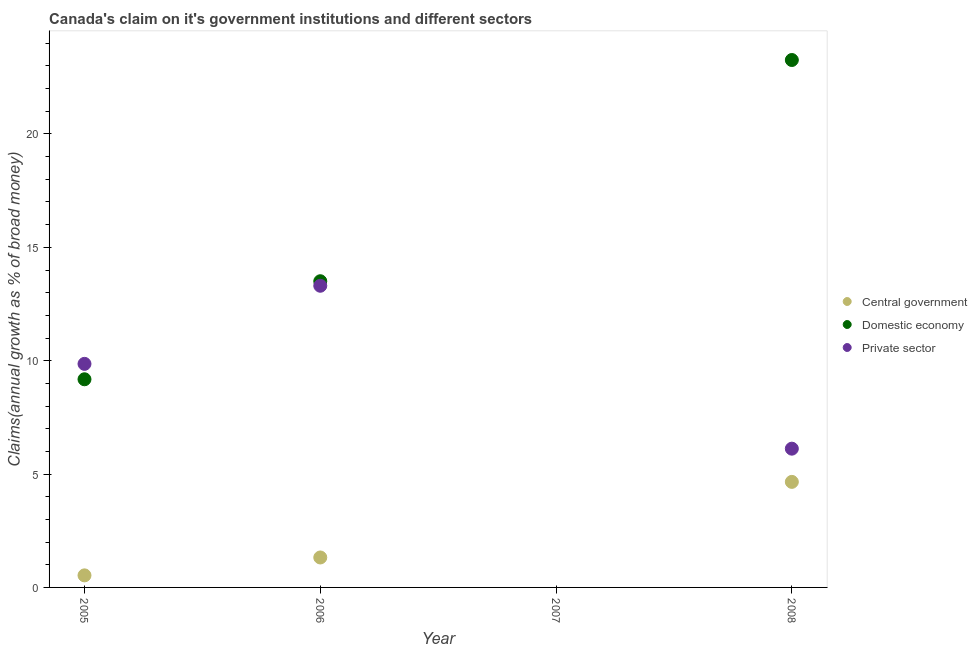Is the number of dotlines equal to the number of legend labels?
Your response must be concise. No. What is the percentage of claim on the private sector in 2006?
Offer a very short reply. 13.31. Across all years, what is the maximum percentage of claim on the domestic economy?
Provide a succinct answer. 23.26. In which year was the percentage of claim on the private sector maximum?
Your answer should be compact. 2006. What is the total percentage of claim on the central government in the graph?
Provide a short and direct response. 6.51. What is the difference between the percentage of claim on the domestic economy in 2005 and that in 2008?
Offer a terse response. -14.08. What is the difference between the percentage of claim on the private sector in 2008 and the percentage of claim on the central government in 2005?
Ensure brevity in your answer.  5.59. What is the average percentage of claim on the domestic economy per year?
Provide a short and direct response. 11.49. In the year 2005, what is the difference between the percentage of claim on the domestic economy and percentage of claim on the private sector?
Keep it short and to the point. -0.68. What is the ratio of the percentage of claim on the private sector in 2005 to that in 2006?
Provide a succinct answer. 0.74. Is the difference between the percentage of claim on the domestic economy in 2006 and 2008 greater than the difference between the percentage of claim on the central government in 2006 and 2008?
Offer a very short reply. No. What is the difference between the highest and the second highest percentage of claim on the domestic economy?
Your answer should be compact. 9.76. What is the difference between the highest and the lowest percentage of claim on the central government?
Your answer should be very brief. 4.65. In how many years, is the percentage of claim on the domestic economy greater than the average percentage of claim on the domestic economy taken over all years?
Provide a succinct answer. 2. Is it the case that in every year, the sum of the percentage of claim on the central government and percentage of claim on the domestic economy is greater than the percentage of claim on the private sector?
Make the answer very short. No. How many dotlines are there?
Your response must be concise. 3. How many years are there in the graph?
Make the answer very short. 4. Are the values on the major ticks of Y-axis written in scientific E-notation?
Offer a terse response. No. Does the graph contain grids?
Your answer should be very brief. No. How are the legend labels stacked?
Provide a short and direct response. Vertical. What is the title of the graph?
Give a very brief answer. Canada's claim on it's government institutions and different sectors. What is the label or title of the X-axis?
Ensure brevity in your answer.  Year. What is the label or title of the Y-axis?
Your response must be concise. Claims(annual growth as % of broad money). What is the Claims(annual growth as % of broad money) in Central government in 2005?
Offer a very short reply. 0.53. What is the Claims(annual growth as % of broad money) in Domestic economy in 2005?
Make the answer very short. 9.18. What is the Claims(annual growth as % of broad money) of Private sector in 2005?
Provide a short and direct response. 9.86. What is the Claims(annual growth as % of broad money) in Central government in 2006?
Your answer should be very brief. 1.32. What is the Claims(annual growth as % of broad money) of Domestic economy in 2006?
Ensure brevity in your answer.  13.5. What is the Claims(annual growth as % of broad money) of Private sector in 2006?
Offer a terse response. 13.31. What is the Claims(annual growth as % of broad money) of Central government in 2007?
Your answer should be very brief. 0. What is the Claims(annual growth as % of broad money) in Private sector in 2007?
Give a very brief answer. 0. What is the Claims(annual growth as % of broad money) of Central government in 2008?
Provide a succinct answer. 4.65. What is the Claims(annual growth as % of broad money) of Domestic economy in 2008?
Give a very brief answer. 23.26. What is the Claims(annual growth as % of broad money) in Private sector in 2008?
Your response must be concise. 6.12. Across all years, what is the maximum Claims(annual growth as % of broad money) of Central government?
Your answer should be compact. 4.65. Across all years, what is the maximum Claims(annual growth as % of broad money) in Domestic economy?
Make the answer very short. 23.26. Across all years, what is the maximum Claims(annual growth as % of broad money) of Private sector?
Provide a short and direct response. 13.31. Across all years, what is the minimum Claims(annual growth as % of broad money) in Central government?
Give a very brief answer. 0. Across all years, what is the minimum Claims(annual growth as % of broad money) of Private sector?
Provide a short and direct response. 0. What is the total Claims(annual growth as % of broad money) in Central government in the graph?
Provide a short and direct response. 6.51. What is the total Claims(annual growth as % of broad money) of Domestic economy in the graph?
Offer a terse response. 45.95. What is the total Claims(annual growth as % of broad money) in Private sector in the graph?
Your answer should be compact. 29.29. What is the difference between the Claims(annual growth as % of broad money) in Central government in 2005 and that in 2006?
Your response must be concise. -0.79. What is the difference between the Claims(annual growth as % of broad money) in Domestic economy in 2005 and that in 2006?
Keep it short and to the point. -4.32. What is the difference between the Claims(annual growth as % of broad money) of Private sector in 2005 and that in 2006?
Ensure brevity in your answer.  -3.44. What is the difference between the Claims(annual growth as % of broad money) of Central government in 2005 and that in 2008?
Give a very brief answer. -4.12. What is the difference between the Claims(annual growth as % of broad money) of Domestic economy in 2005 and that in 2008?
Your response must be concise. -14.08. What is the difference between the Claims(annual growth as % of broad money) of Private sector in 2005 and that in 2008?
Keep it short and to the point. 3.74. What is the difference between the Claims(annual growth as % of broad money) of Central government in 2006 and that in 2008?
Your answer should be very brief. -3.33. What is the difference between the Claims(annual growth as % of broad money) of Domestic economy in 2006 and that in 2008?
Provide a succinct answer. -9.76. What is the difference between the Claims(annual growth as % of broad money) in Private sector in 2006 and that in 2008?
Provide a short and direct response. 7.18. What is the difference between the Claims(annual growth as % of broad money) of Central government in 2005 and the Claims(annual growth as % of broad money) of Domestic economy in 2006?
Provide a short and direct response. -12.97. What is the difference between the Claims(annual growth as % of broad money) of Central government in 2005 and the Claims(annual growth as % of broad money) of Private sector in 2006?
Your answer should be compact. -12.77. What is the difference between the Claims(annual growth as % of broad money) in Domestic economy in 2005 and the Claims(annual growth as % of broad money) in Private sector in 2006?
Offer a terse response. -4.12. What is the difference between the Claims(annual growth as % of broad money) in Central government in 2005 and the Claims(annual growth as % of broad money) in Domestic economy in 2008?
Offer a terse response. -22.73. What is the difference between the Claims(annual growth as % of broad money) in Central government in 2005 and the Claims(annual growth as % of broad money) in Private sector in 2008?
Offer a very short reply. -5.59. What is the difference between the Claims(annual growth as % of broad money) in Domestic economy in 2005 and the Claims(annual growth as % of broad money) in Private sector in 2008?
Ensure brevity in your answer.  3.06. What is the difference between the Claims(annual growth as % of broad money) of Central government in 2006 and the Claims(annual growth as % of broad money) of Domestic economy in 2008?
Provide a succinct answer. -21.94. What is the difference between the Claims(annual growth as % of broad money) of Central government in 2006 and the Claims(annual growth as % of broad money) of Private sector in 2008?
Your answer should be compact. -4.8. What is the difference between the Claims(annual growth as % of broad money) in Domestic economy in 2006 and the Claims(annual growth as % of broad money) in Private sector in 2008?
Your answer should be very brief. 7.38. What is the average Claims(annual growth as % of broad money) of Central government per year?
Make the answer very short. 1.63. What is the average Claims(annual growth as % of broad money) of Domestic economy per year?
Ensure brevity in your answer.  11.49. What is the average Claims(annual growth as % of broad money) in Private sector per year?
Provide a succinct answer. 7.32. In the year 2005, what is the difference between the Claims(annual growth as % of broad money) in Central government and Claims(annual growth as % of broad money) in Domestic economy?
Give a very brief answer. -8.65. In the year 2005, what is the difference between the Claims(annual growth as % of broad money) of Central government and Claims(annual growth as % of broad money) of Private sector?
Your answer should be compact. -9.33. In the year 2005, what is the difference between the Claims(annual growth as % of broad money) in Domestic economy and Claims(annual growth as % of broad money) in Private sector?
Give a very brief answer. -0.68. In the year 2006, what is the difference between the Claims(annual growth as % of broad money) of Central government and Claims(annual growth as % of broad money) of Domestic economy?
Your response must be concise. -12.18. In the year 2006, what is the difference between the Claims(annual growth as % of broad money) of Central government and Claims(annual growth as % of broad money) of Private sector?
Keep it short and to the point. -11.98. In the year 2006, what is the difference between the Claims(annual growth as % of broad money) in Domestic economy and Claims(annual growth as % of broad money) in Private sector?
Give a very brief answer. 0.2. In the year 2008, what is the difference between the Claims(annual growth as % of broad money) of Central government and Claims(annual growth as % of broad money) of Domestic economy?
Provide a succinct answer. -18.61. In the year 2008, what is the difference between the Claims(annual growth as % of broad money) of Central government and Claims(annual growth as % of broad money) of Private sector?
Provide a succinct answer. -1.47. In the year 2008, what is the difference between the Claims(annual growth as % of broad money) in Domestic economy and Claims(annual growth as % of broad money) in Private sector?
Ensure brevity in your answer.  17.14. What is the ratio of the Claims(annual growth as % of broad money) in Central government in 2005 to that in 2006?
Give a very brief answer. 0.4. What is the ratio of the Claims(annual growth as % of broad money) of Domestic economy in 2005 to that in 2006?
Offer a terse response. 0.68. What is the ratio of the Claims(annual growth as % of broad money) in Private sector in 2005 to that in 2006?
Your answer should be compact. 0.74. What is the ratio of the Claims(annual growth as % of broad money) of Central government in 2005 to that in 2008?
Ensure brevity in your answer.  0.11. What is the ratio of the Claims(annual growth as % of broad money) of Domestic economy in 2005 to that in 2008?
Give a very brief answer. 0.39. What is the ratio of the Claims(annual growth as % of broad money) of Private sector in 2005 to that in 2008?
Your response must be concise. 1.61. What is the ratio of the Claims(annual growth as % of broad money) in Central government in 2006 to that in 2008?
Ensure brevity in your answer.  0.28. What is the ratio of the Claims(annual growth as % of broad money) of Domestic economy in 2006 to that in 2008?
Provide a short and direct response. 0.58. What is the ratio of the Claims(annual growth as % of broad money) of Private sector in 2006 to that in 2008?
Provide a short and direct response. 2.17. What is the difference between the highest and the second highest Claims(annual growth as % of broad money) of Central government?
Ensure brevity in your answer.  3.33. What is the difference between the highest and the second highest Claims(annual growth as % of broad money) of Domestic economy?
Give a very brief answer. 9.76. What is the difference between the highest and the second highest Claims(annual growth as % of broad money) in Private sector?
Your answer should be very brief. 3.44. What is the difference between the highest and the lowest Claims(annual growth as % of broad money) in Central government?
Offer a terse response. 4.66. What is the difference between the highest and the lowest Claims(annual growth as % of broad money) of Domestic economy?
Provide a succinct answer. 23.26. What is the difference between the highest and the lowest Claims(annual growth as % of broad money) of Private sector?
Ensure brevity in your answer.  13.3. 